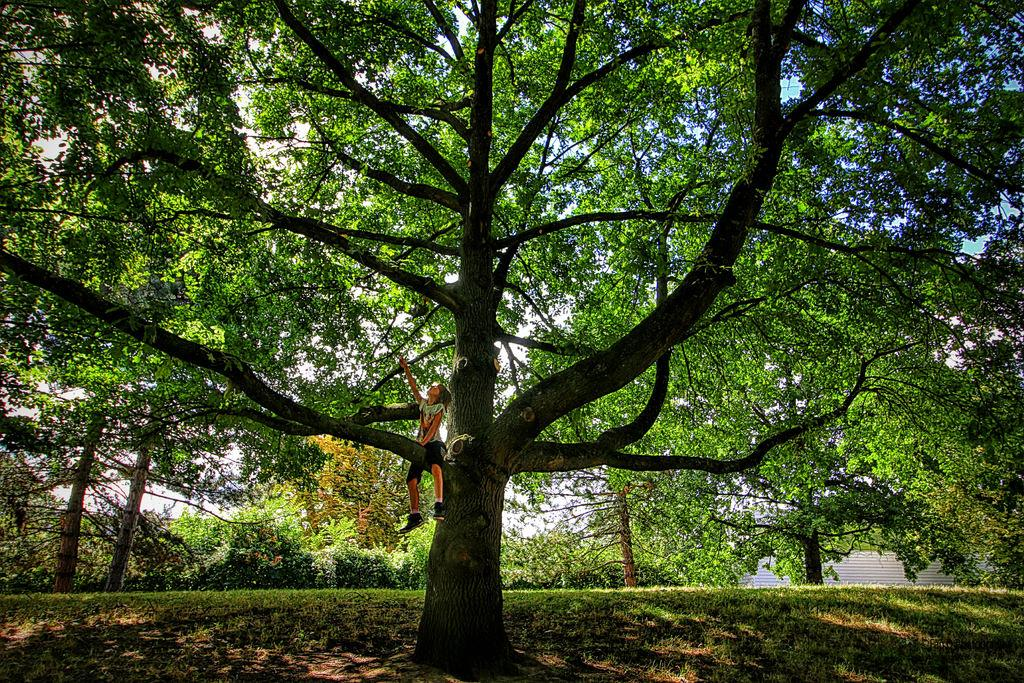What type of vegetation can be seen in the image? There is grass, plants, and trees in the image. Can you describe the person in the image? There is a person sitting on the branch of a tree in the image. What is visible in the background of the image? The sky is visible in the background of the image. What type of flavor can be tasted in the sky in the image? There is no flavor present in the sky in the image, as the sky is a natural atmospheric phenomenon and does not have a taste. 